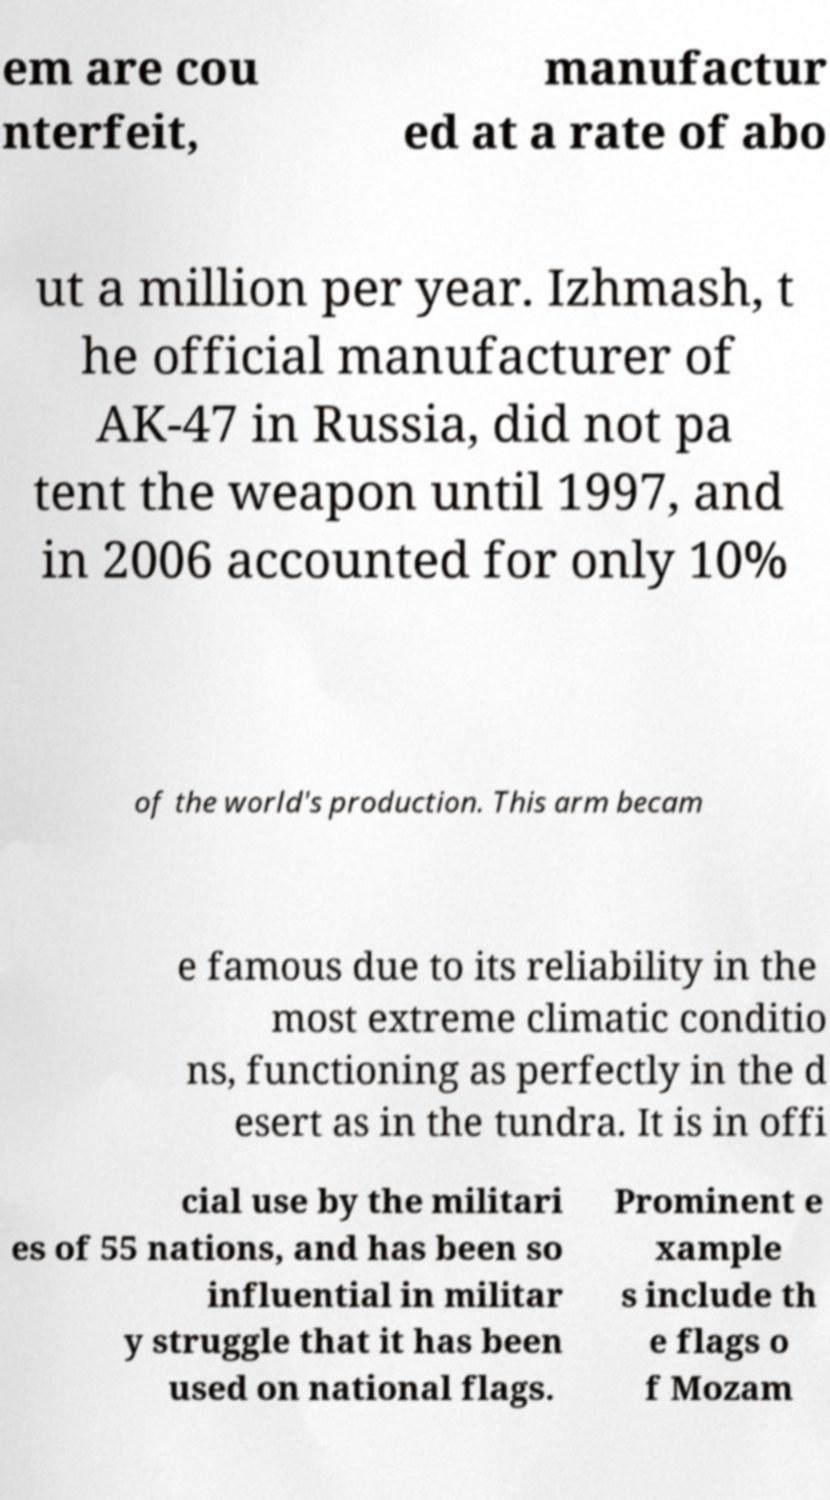Could you assist in decoding the text presented in this image and type it out clearly? em are cou nterfeit, manufactur ed at a rate of abo ut a million per year. Izhmash, t he official manufacturer of AK-47 in Russia, did not pa tent the weapon until 1997, and in 2006 accounted for only 10% of the world's production. This arm becam e famous due to its reliability in the most extreme climatic conditio ns, functioning as perfectly in the d esert as in the tundra. It is in offi cial use by the militari es of 55 nations, and has been so influential in militar y struggle that it has been used on national flags. Prominent e xample s include th e flags o f Mozam 